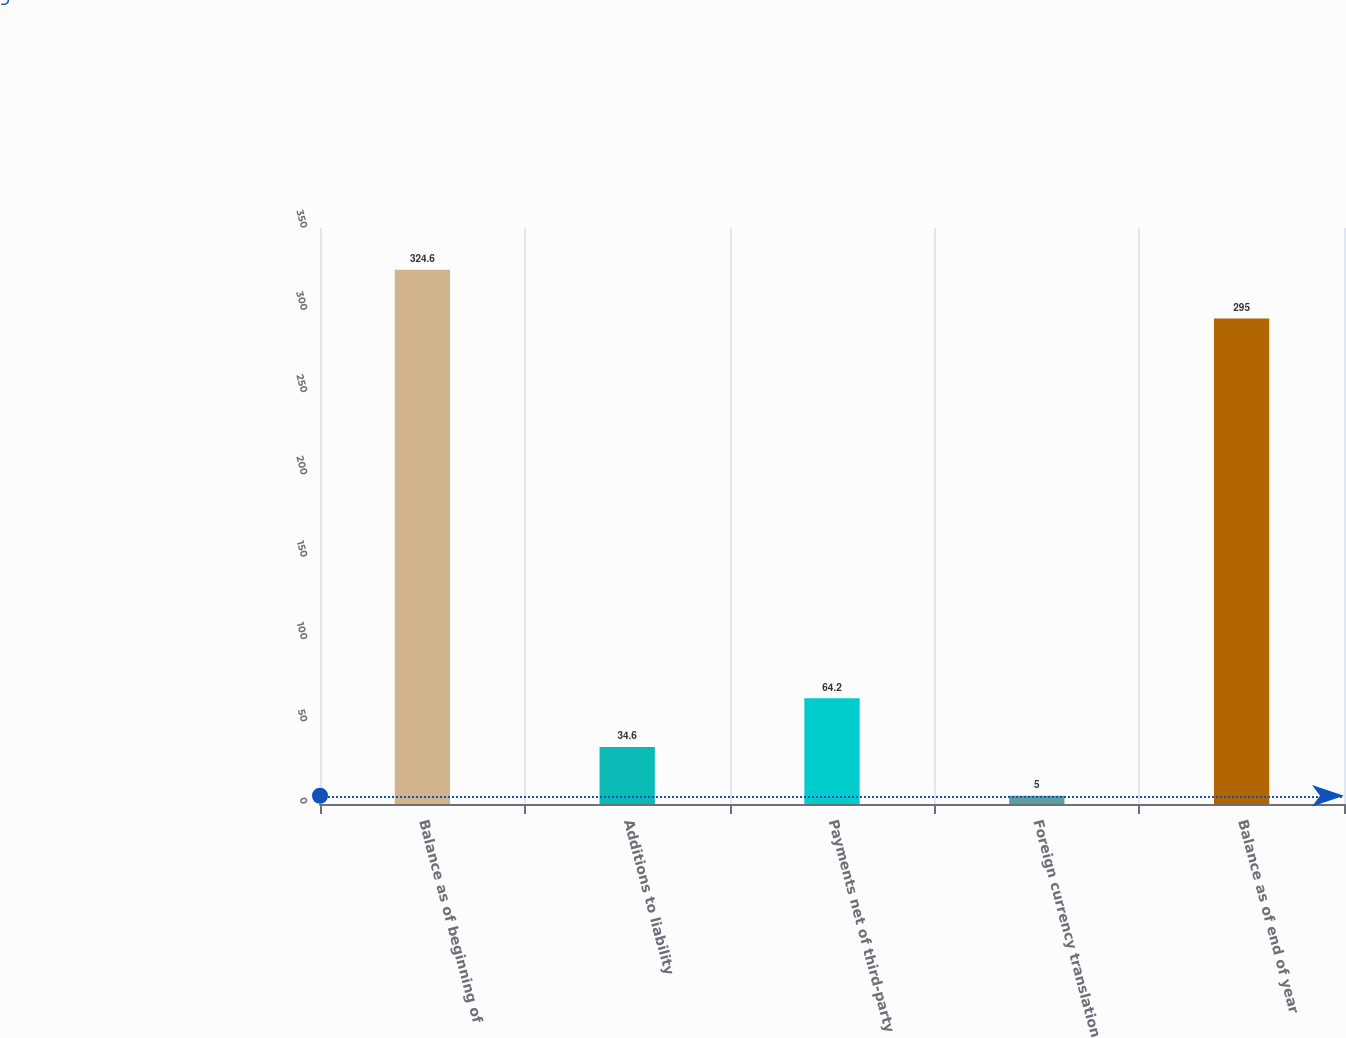Convert chart to OTSL. <chart><loc_0><loc_0><loc_500><loc_500><bar_chart><fcel>Balance as of beginning of<fcel>Additions to liability<fcel>Payments net of third-party<fcel>Foreign currency translation<fcel>Balance as of end of year<nl><fcel>324.6<fcel>34.6<fcel>64.2<fcel>5<fcel>295<nl></chart> 